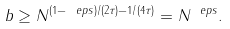Convert formula to latex. <formula><loc_0><loc_0><loc_500><loc_500>b \geq N ^ { ( 1 - \ e p s ) / ( 2 \tau ) - 1 / ( 4 \tau ) } = N ^ { \ e p s } .</formula> 